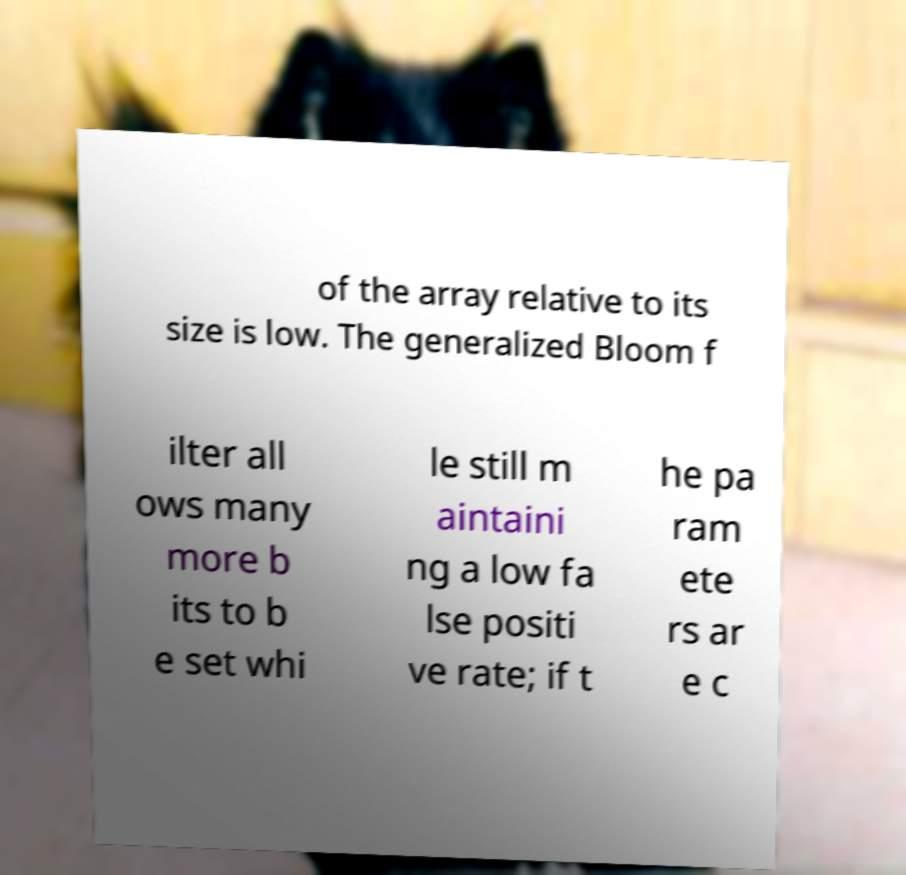I need the written content from this picture converted into text. Can you do that? of the array relative to its size is low. The generalized Bloom f ilter all ows many more b its to b e set whi le still m aintaini ng a low fa lse positi ve rate; if t he pa ram ete rs ar e c 